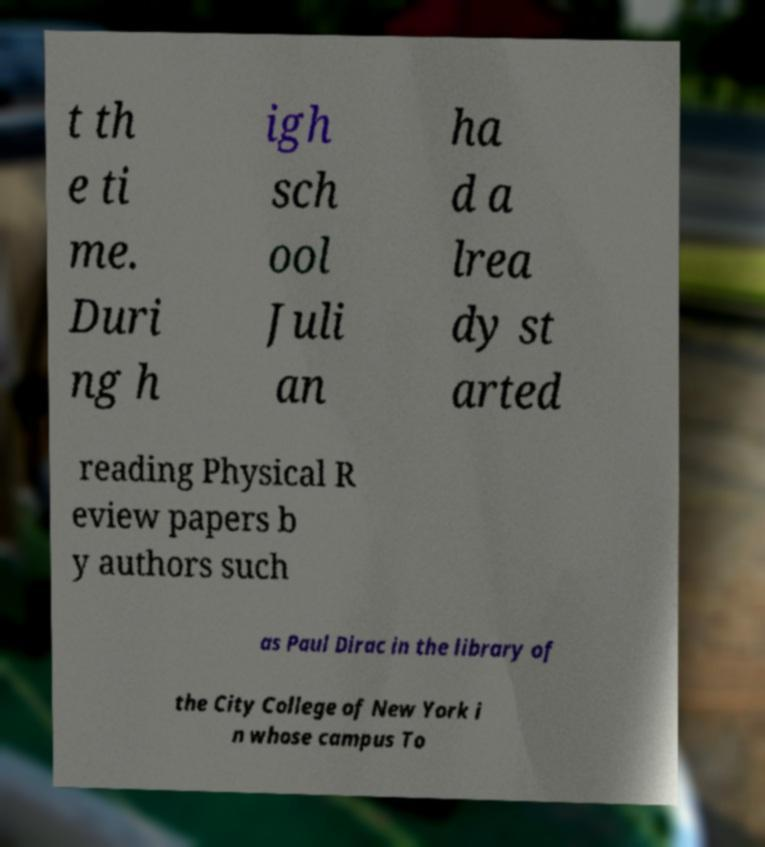Could you extract and type out the text from this image? t th e ti me. Duri ng h igh sch ool Juli an ha d a lrea dy st arted reading Physical R eview papers b y authors such as Paul Dirac in the library of the City College of New York i n whose campus To 